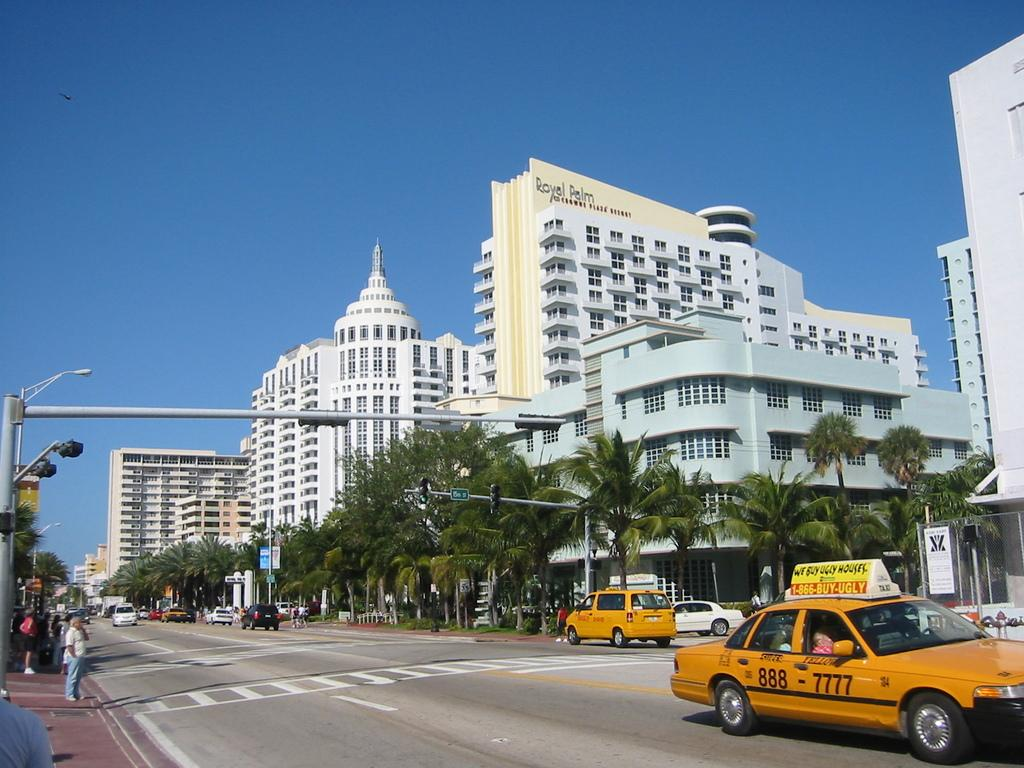<image>
Create a compact narrative representing the image presented. the number 888 that is on a car 